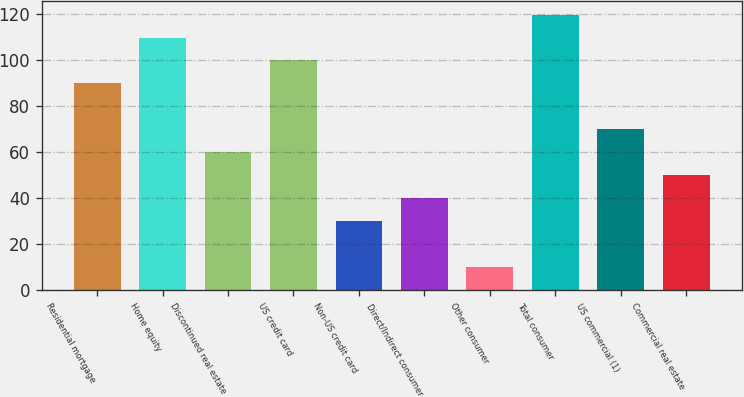Convert chart to OTSL. <chart><loc_0><loc_0><loc_500><loc_500><bar_chart><fcel>Residential mortgage<fcel>Home equity<fcel>Discontinued real estate<fcel>US credit card<fcel>Non-US credit card<fcel>Direct/Indirect consumer<fcel>Other consumer<fcel>Total consumer<fcel>US commercial (1)<fcel>Commercial real estate<nl><fcel>90<fcel>109.94<fcel>60.09<fcel>99.97<fcel>30.18<fcel>40.15<fcel>10.24<fcel>119.91<fcel>70.06<fcel>50.12<nl></chart> 